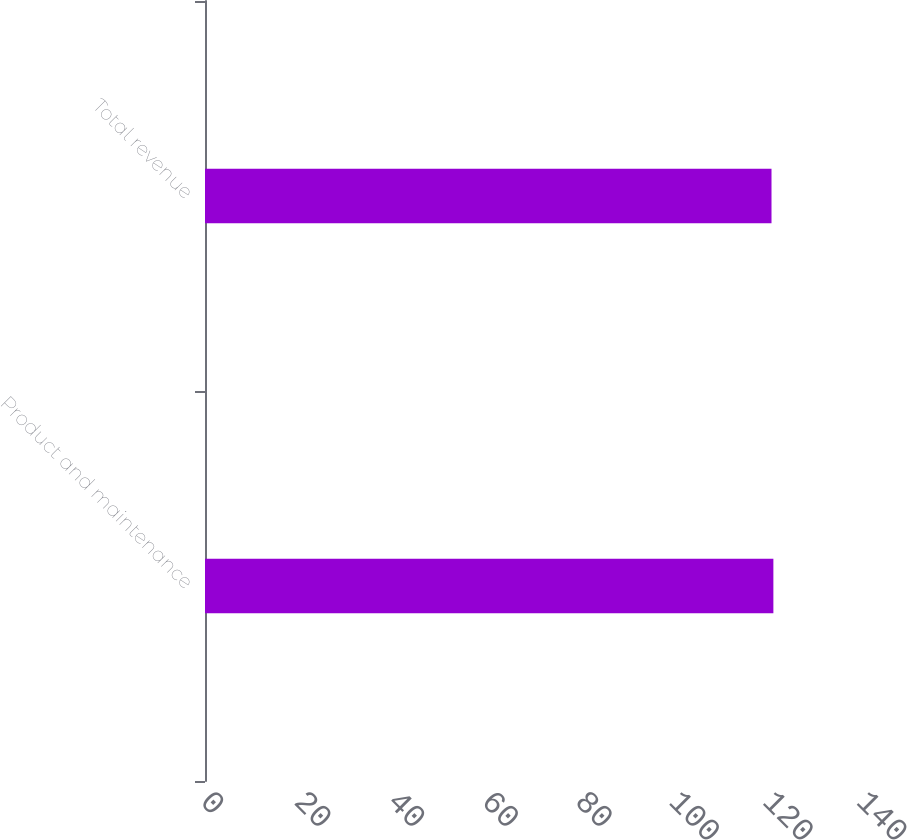Convert chart. <chart><loc_0><loc_0><loc_500><loc_500><bar_chart><fcel>Product and maintenance<fcel>Total revenue<nl><fcel>121.3<fcel>120.9<nl></chart> 